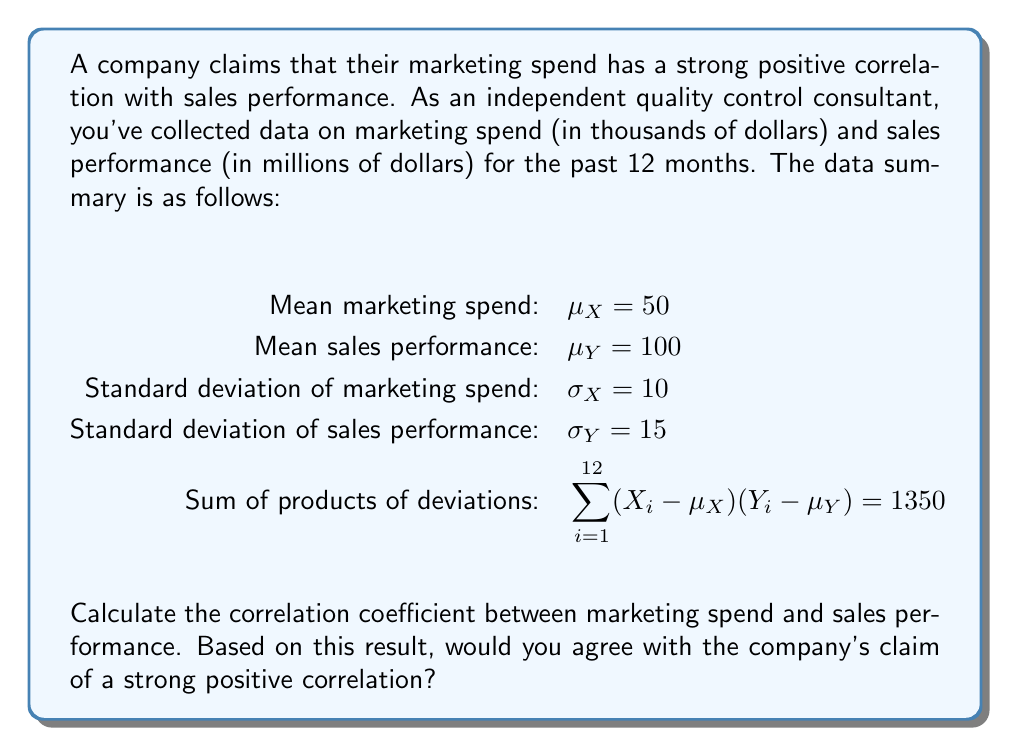Could you help me with this problem? To calculate the correlation coefficient between marketing spend (X) and sales performance (Y), we'll use the formula:

$$ r_{XY} = \frac{\text{Cov}(X,Y)}{\sigma_X \sigma_Y} $$

Where $\text{Cov}(X,Y)$ is the covariance between X and Y.

Step 1: Calculate the covariance
The covariance can be computed using:

$$ \text{Cov}(X,Y) = \frac{1}{n} \sum_{i=1}^{n} (X_i - \mu_X)(Y_i - \mu_Y) $$

Given that $\sum_{i=1}^{12} (X_i - \mu_X)(Y_i - \mu_Y) = 1350$ and $n = 12$, we have:

$$ \text{Cov}(X,Y) = \frac{1350}{12} = 112.5 $$

Step 2: Calculate the correlation coefficient
Now we can substitute the values into the correlation coefficient formula:

$$ r_{XY} = \frac{112.5}{10 \cdot 15} = \frac{112.5}{150} = 0.75 $$

Step 3: Interpret the result
The correlation coefficient ranges from -1 to 1, where:
- Values close to 1 indicate a strong positive correlation
- Values close to -1 indicate a strong negative correlation
- Values close to 0 indicate a weak or no correlation

A correlation coefficient of 0.75 suggests a moderately strong positive correlation between marketing spend and sales performance. However, as a skeptical consultant, it's important to note that:

1. Correlation does not imply causation.
2. Other factors might influence sales performance.
3. The sample size (12 months) is relatively small for drawing definitive conclusions.
4. The strength of the correlation might be exaggerated in the company's claim.
Answer: The correlation coefficient between marketing spend and sales performance is 0.75. While this indicates a moderately strong positive correlation, a skeptical quality control consultant would not necessarily agree with the company's claim of a "strong" positive correlation without further investigation and consideration of other factors that may influence sales performance. 